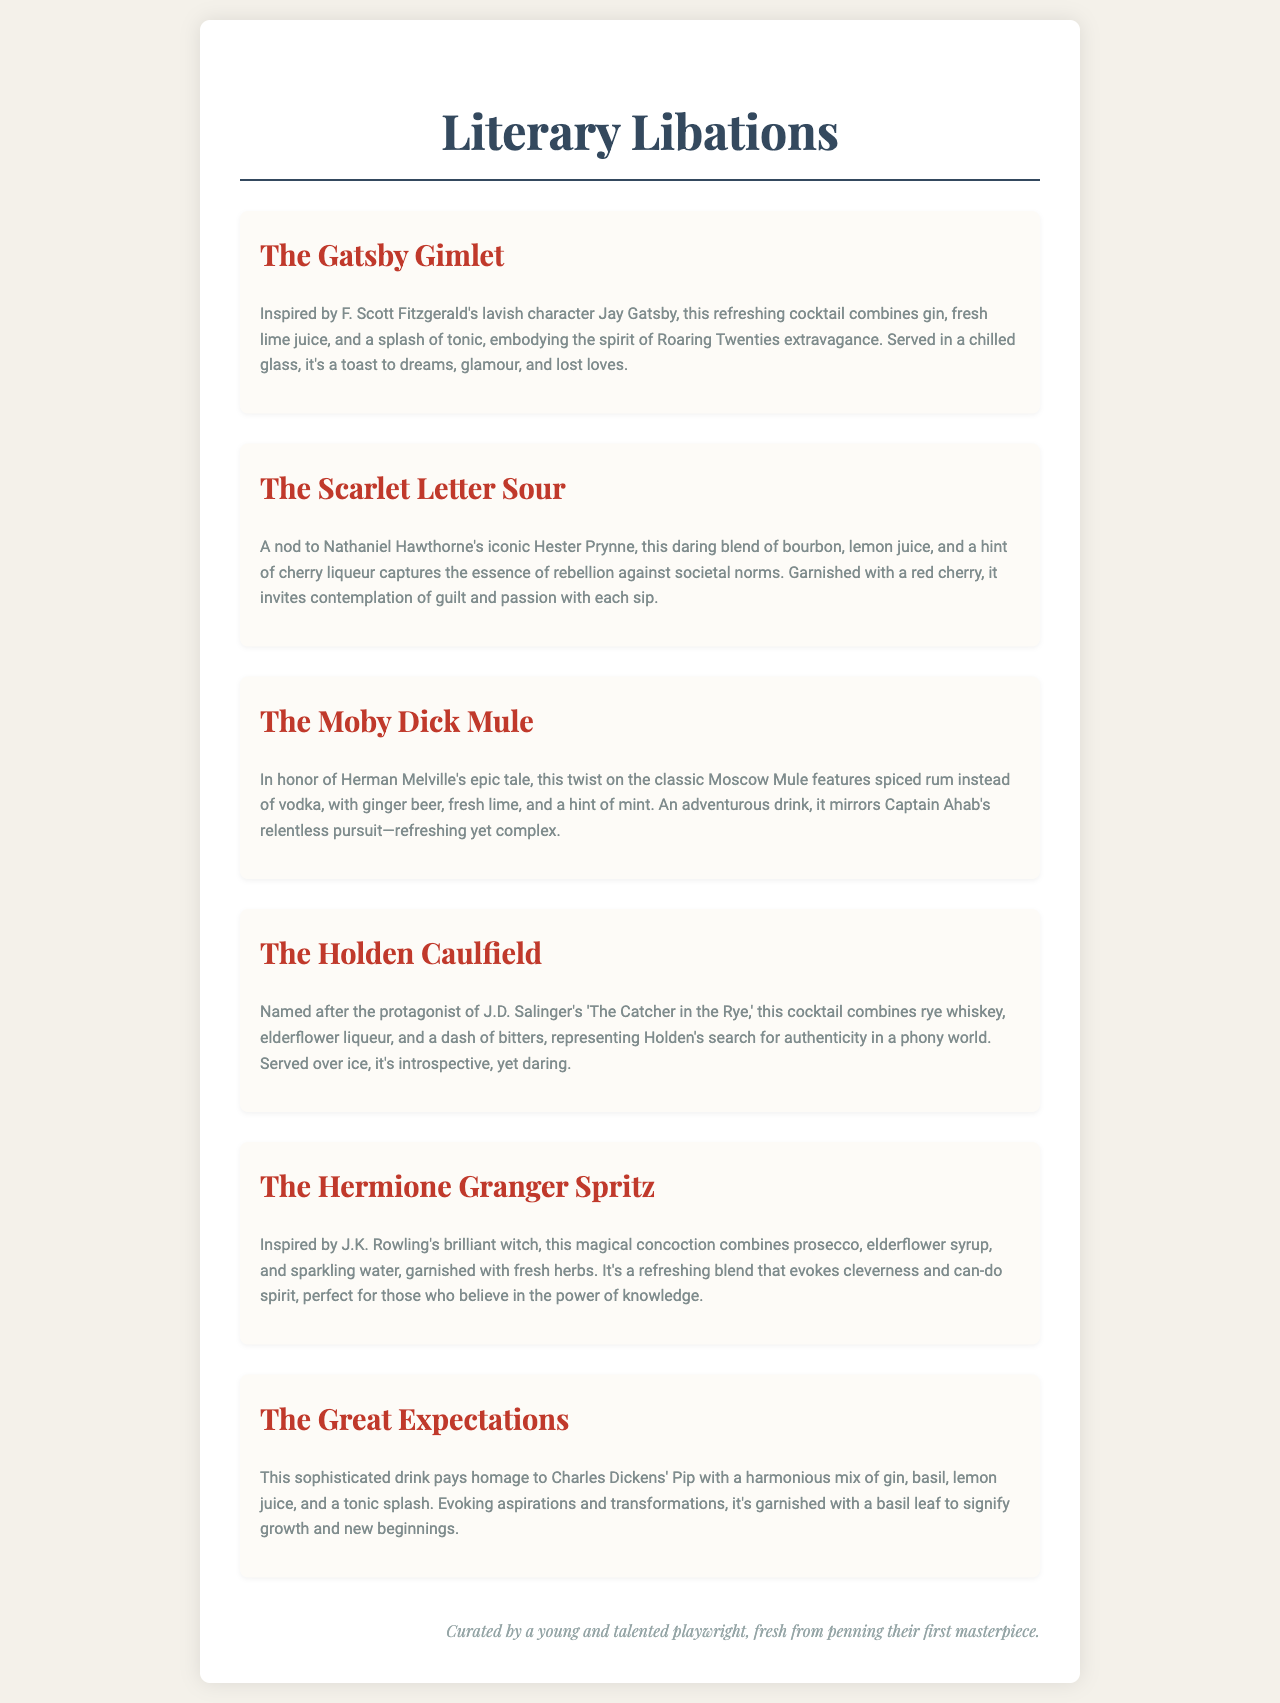What is the title of the cocktail inspired by Jay Gatsby? The title of the cocktail inspired by Jay Gatsby is mentioned at the beginning of the description for that drink.
Answer: The Gatsby Gimlet What type of spirit is used in The Scarlet Letter Sour? The type of spirit used in The Scarlet Letter Sour is specified in the description of the drink.
Answer: Bourbon Which cocktail features ginger beer? The cocktail that features ginger beer is described in the section about Herman Melville's epic tale.
Answer: The Moby Dick Mule How many cocktails are listed in the menu? The total number of cocktails can be counted from the document, which presents them one by one.
Answer: Six What garnish is used in The Hermione Granger Spritz? The garnish for The Hermione Granger Spritz is detailed in its description.
Answer: Fresh herbs Which cocktail represents Holden Caulfield? The cocktail that represents Holden Caulfield is directly named in the title section for that drink.
Answer: The Holden Caulfield What literary work is referenced in relation to The Great Expectations cocktail? The literary work referenced for The Great Expectations cocktail can be found in the description.
Answer: Great Expectations What theme does The Gatsby Gimlet evoke? The theme that The Gatsby Gimlet evokes is captured in the description of the drink.
Answer: Dreams, glamour, and lost loves 